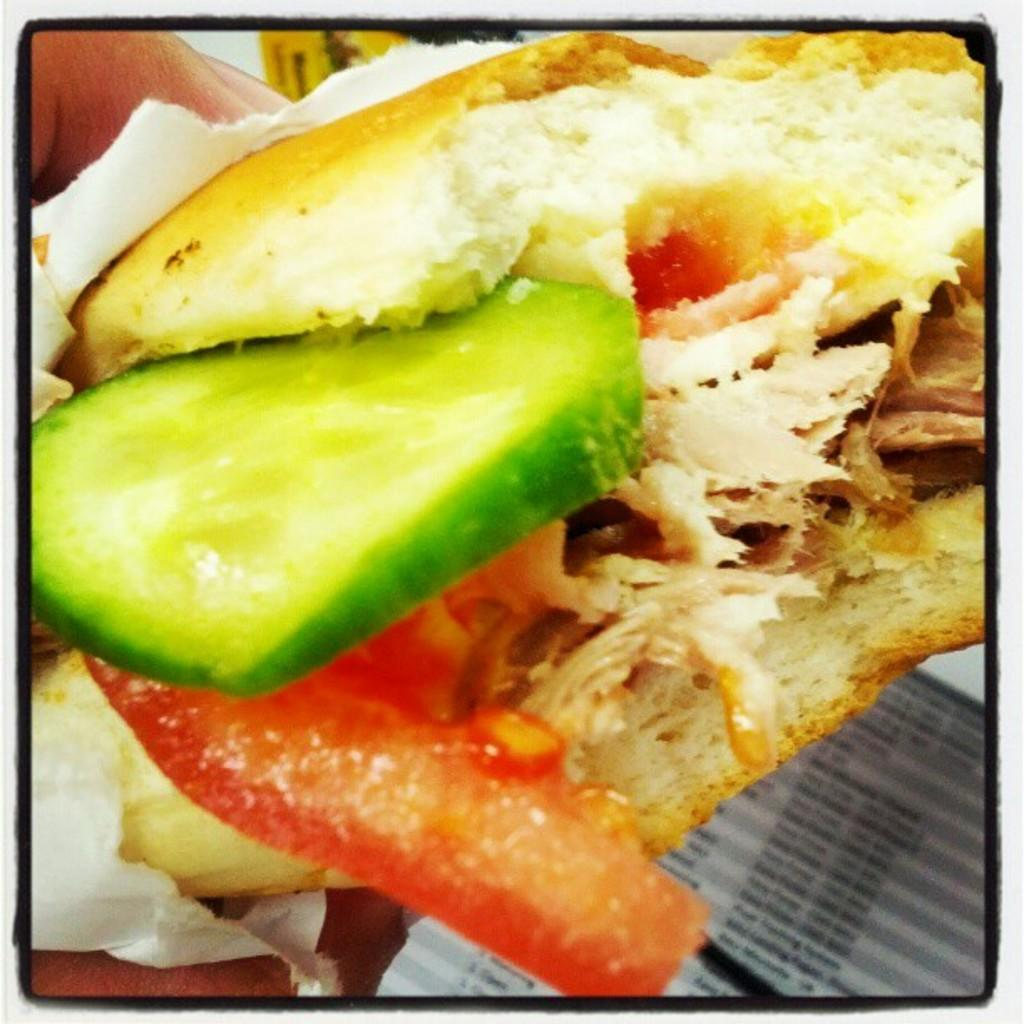What is the main subject of the image? There is a food item in the image. Can you describe any other elements in the image? A hand is visible in the image, and there is also a paper present. How many mists can be seen in the image? There is no mist present in the image. What type of scissors are being used to cut the paper in the image? There are no scissors visible in the image. 